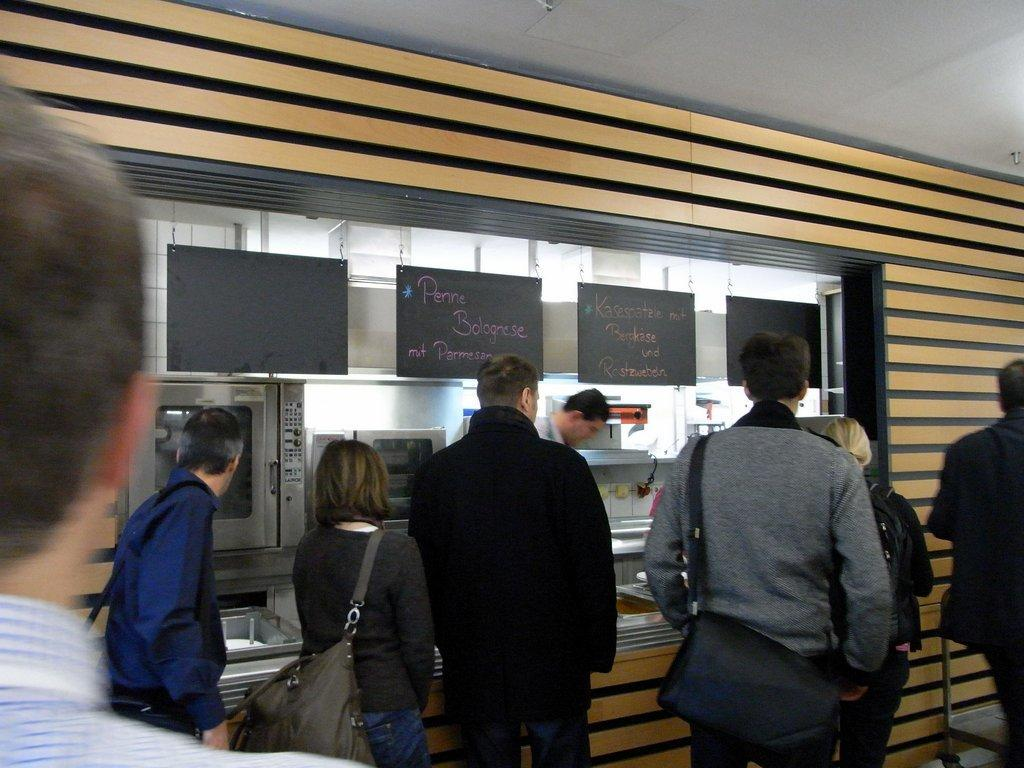What type of establishment is depicted in the image? There is a shop in the image. What are the people in the image doing? The people are in a queue waiting to take products from the shop. What type of oil is being used to heat the pot in the image? There is no pot or oil present in the image; it only features a shop and people waiting in a queue. 